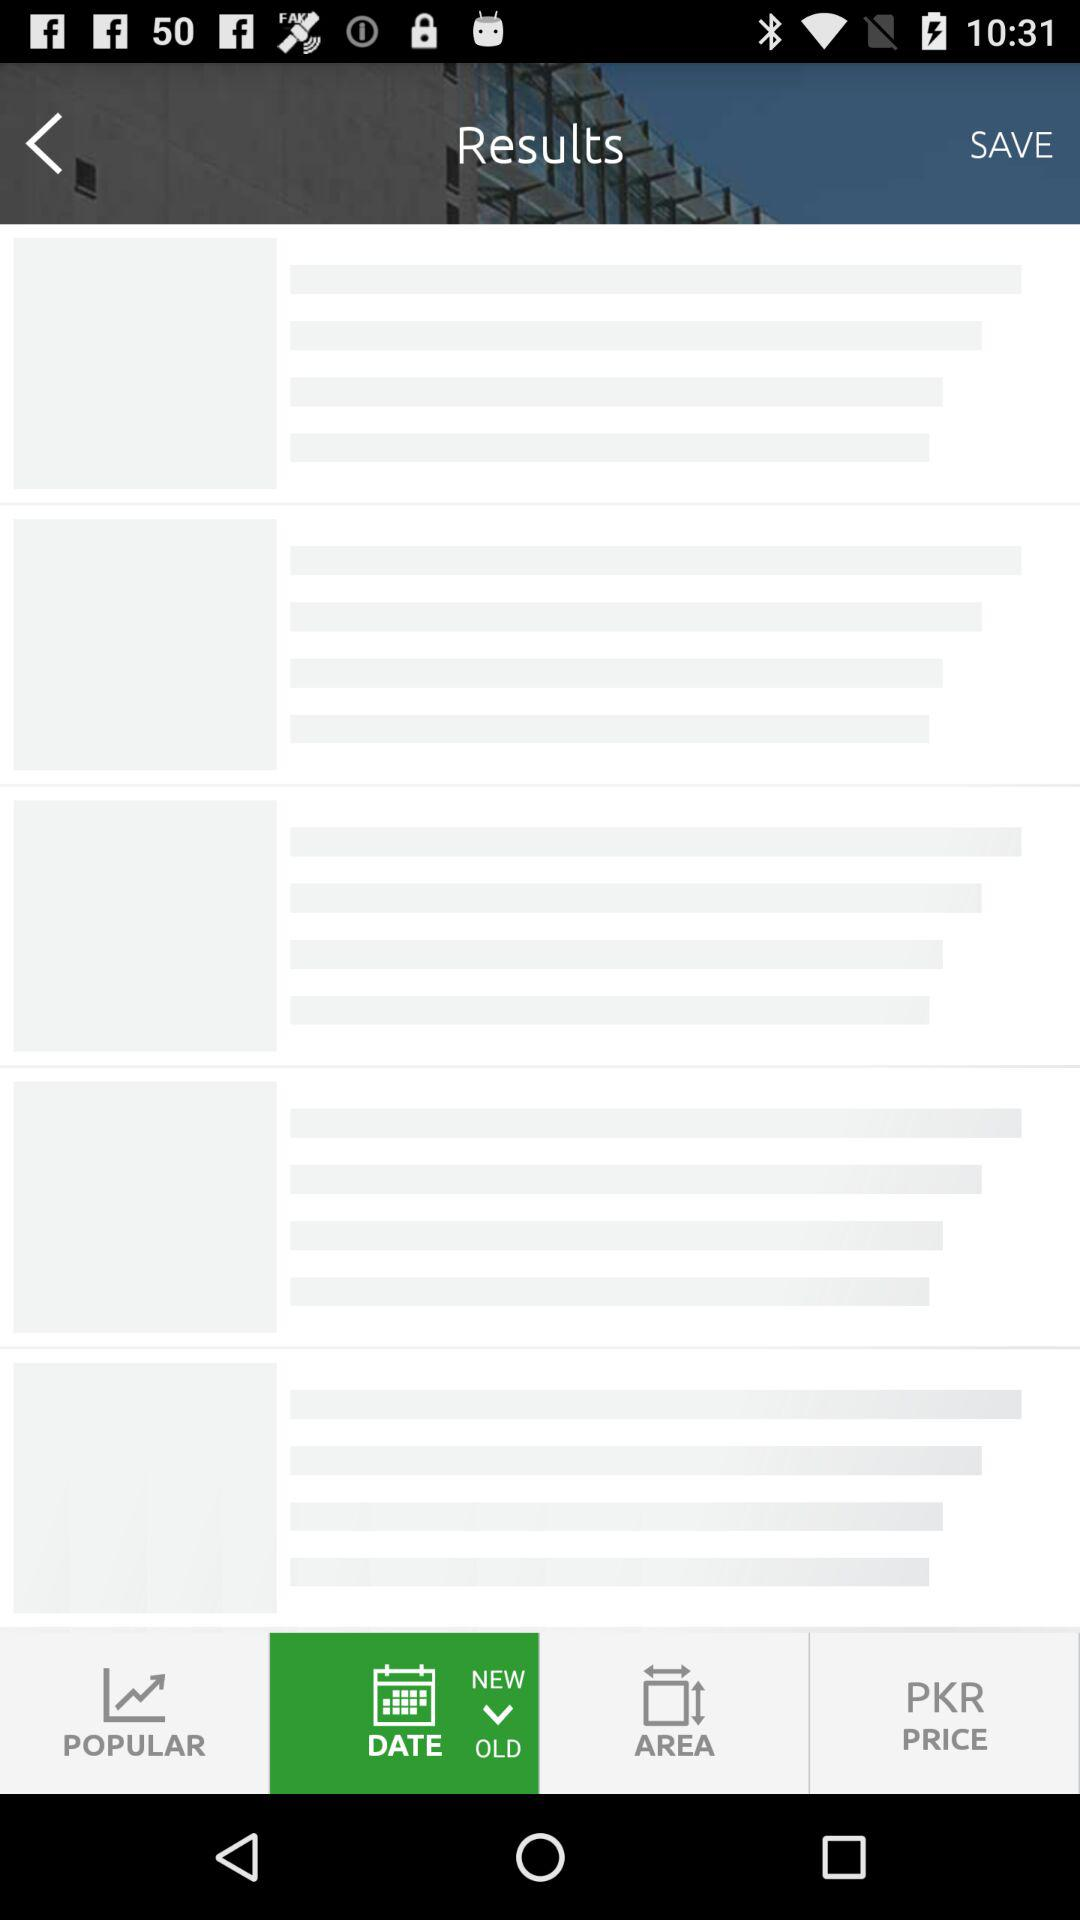How many beds does the property have?
Answer the question using a single word or phrase. 5 